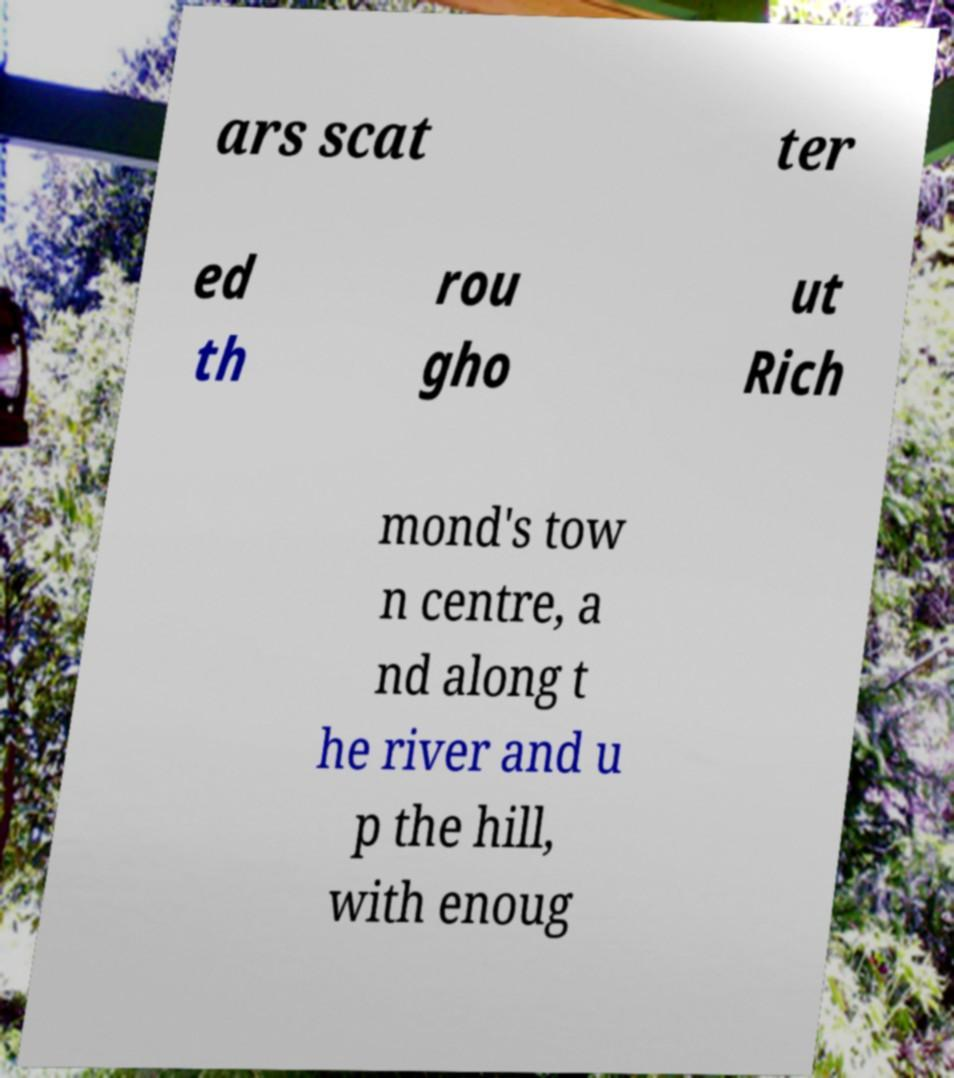Can you accurately transcribe the text from the provided image for me? ars scat ter ed th rou gho ut Rich mond's tow n centre, a nd along t he river and u p the hill, with enoug 